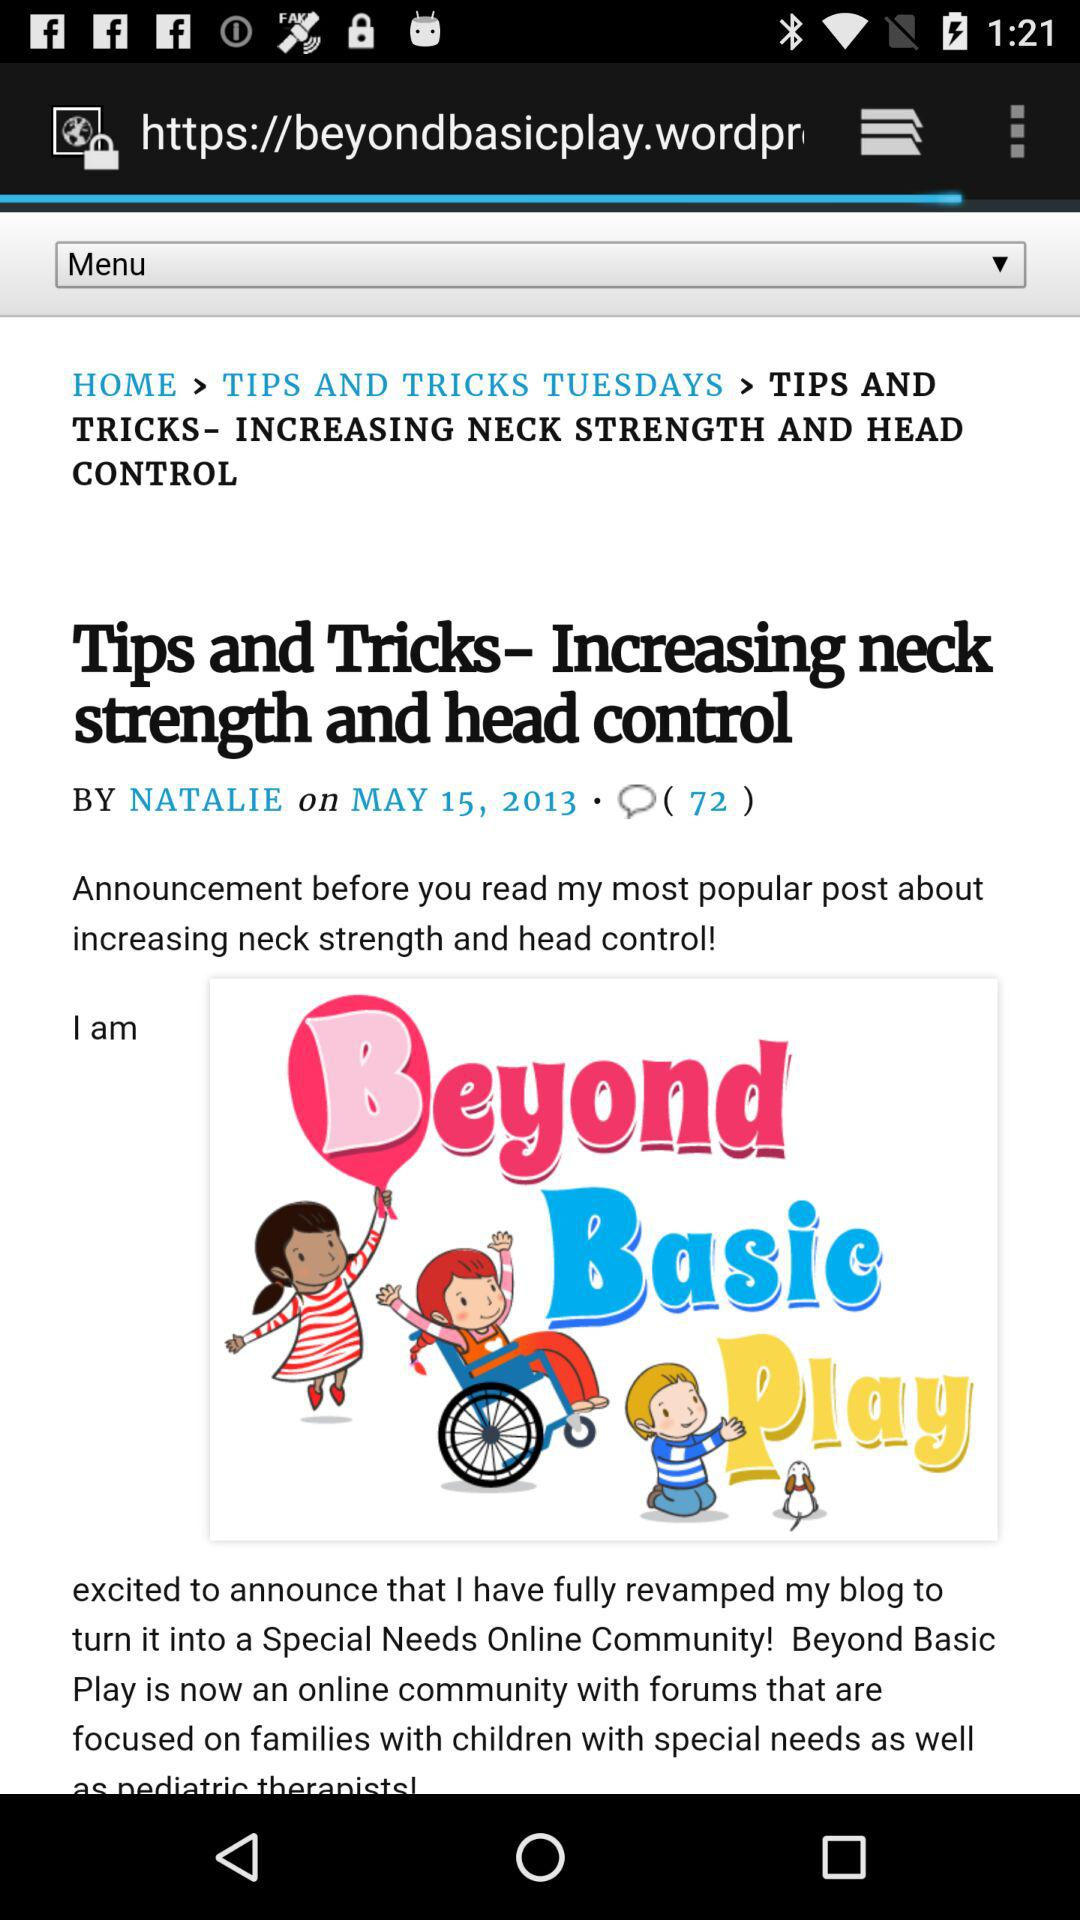What is the title of the article? The title of the article is "Tips and Tricks- Increasing neck strength and head control". 